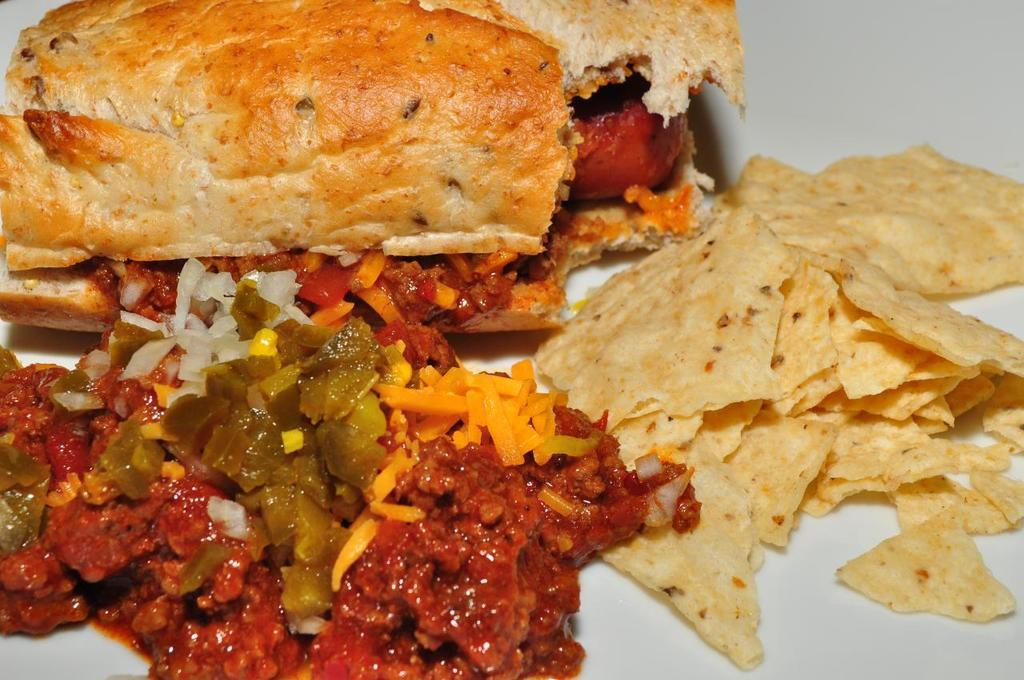What type of food can be seen in the image? There is bread and corn chips in the image. What other dish is visible in the image? There is curry in the image. What type of flesh can be seen in the image? There is no flesh present in the image; it features bread, corn chips, and curry. Who is the governor in the image? There is no governor present in the image. 